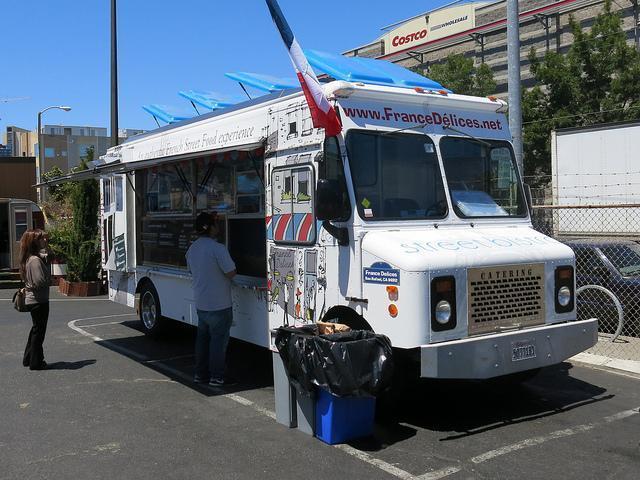How many trucks are there?
Give a very brief answer. 1. How many people are in the photo?
Give a very brief answer. 2. 